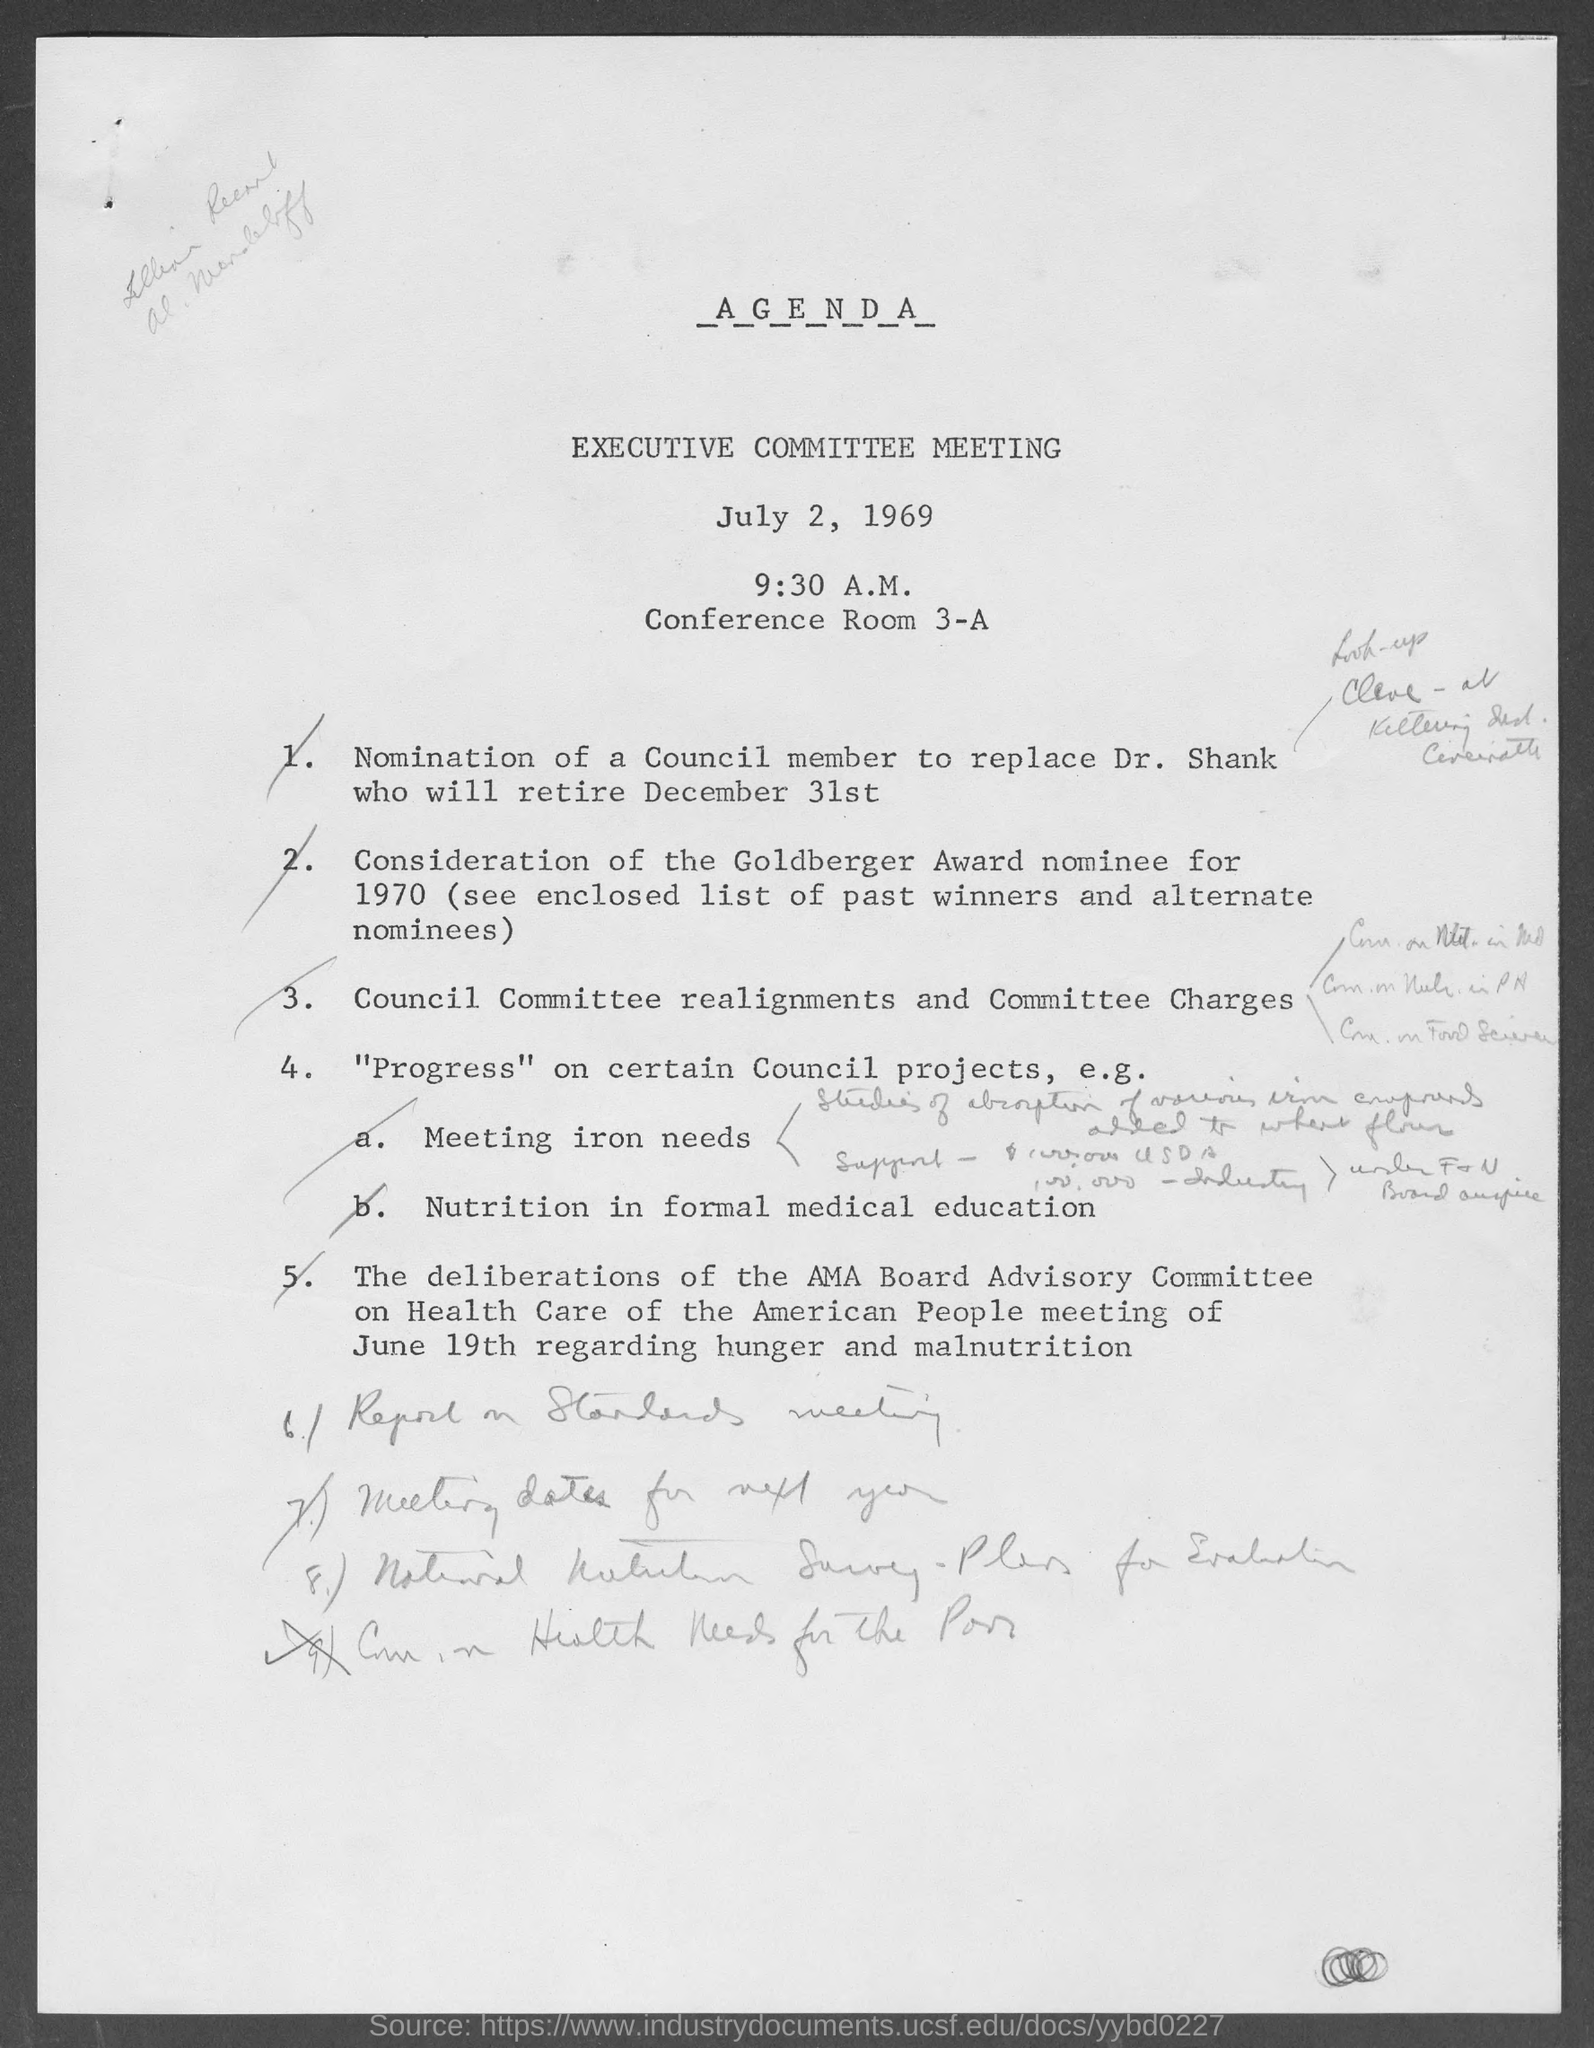What is the name of the meeting ?
Ensure brevity in your answer.  Executive Committee meeting. On which date the meeting was scheduled ?
Give a very brief answer. July 2, 1969. At what time the meeting was scheduled ?
Provide a short and direct response. 9:30 AM. 